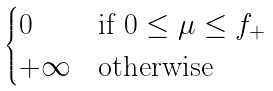Convert formula to latex. <formula><loc_0><loc_0><loc_500><loc_500>\begin{cases} 0 & \text {if } 0 \leq \mu \leq f _ { + } \\ + \infty & \text {otherwise} \end{cases}</formula> 